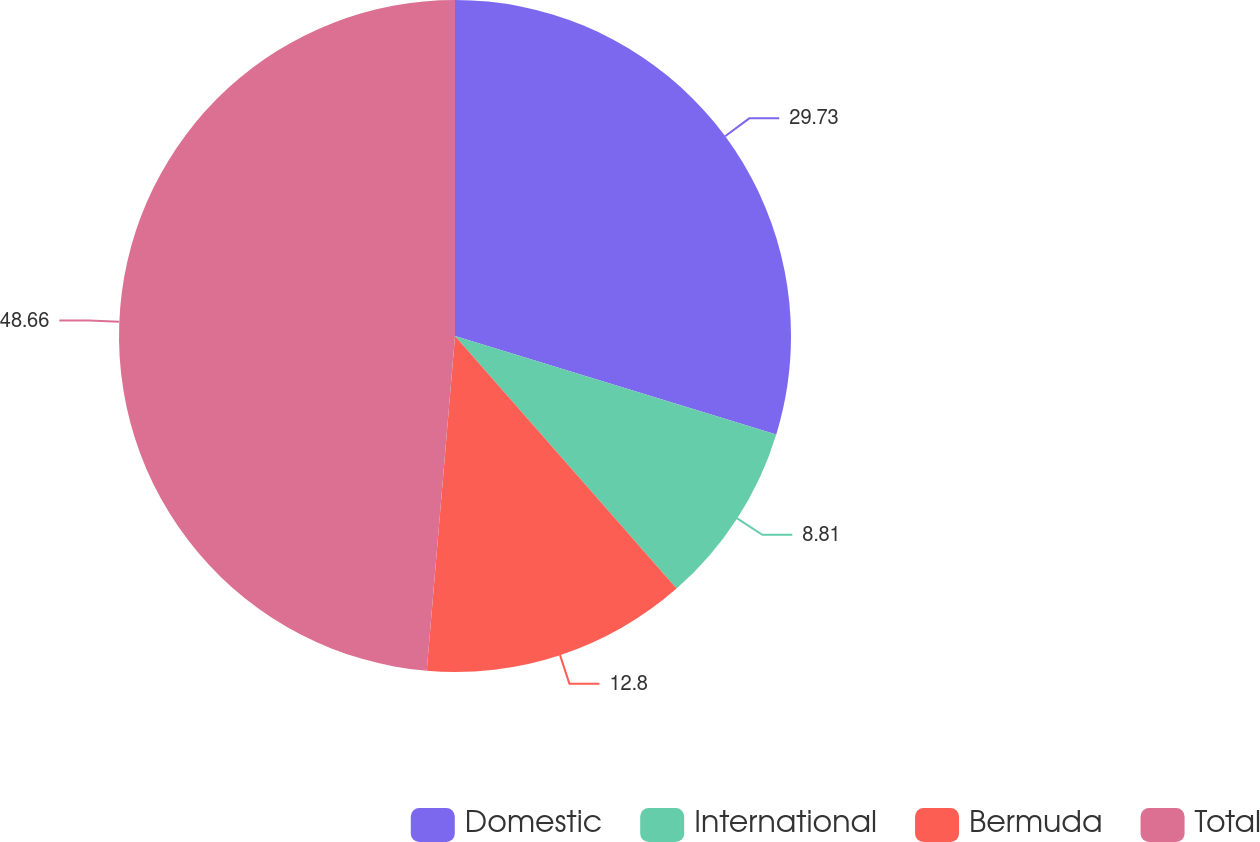Convert chart. <chart><loc_0><loc_0><loc_500><loc_500><pie_chart><fcel>Domestic<fcel>International<fcel>Bermuda<fcel>Total<nl><fcel>29.73%<fcel>8.81%<fcel>12.8%<fcel>48.66%<nl></chart> 